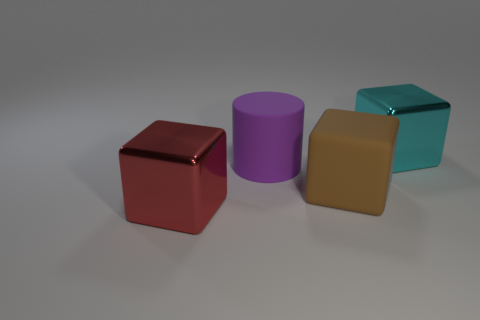Subtract all metal cubes. How many cubes are left? 1 Subtract all cylinders. How many objects are left? 3 Add 1 large purple matte objects. How many objects exist? 5 Add 3 red cubes. How many red cubes exist? 4 Subtract 0 purple blocks. How many objects are left? 4 Subtract all large rubber cubes. Subtract all cubes. How many objects are left? 0 Add 1 large purple matte cylinders. How many large purple matte cylinders are left? 2 